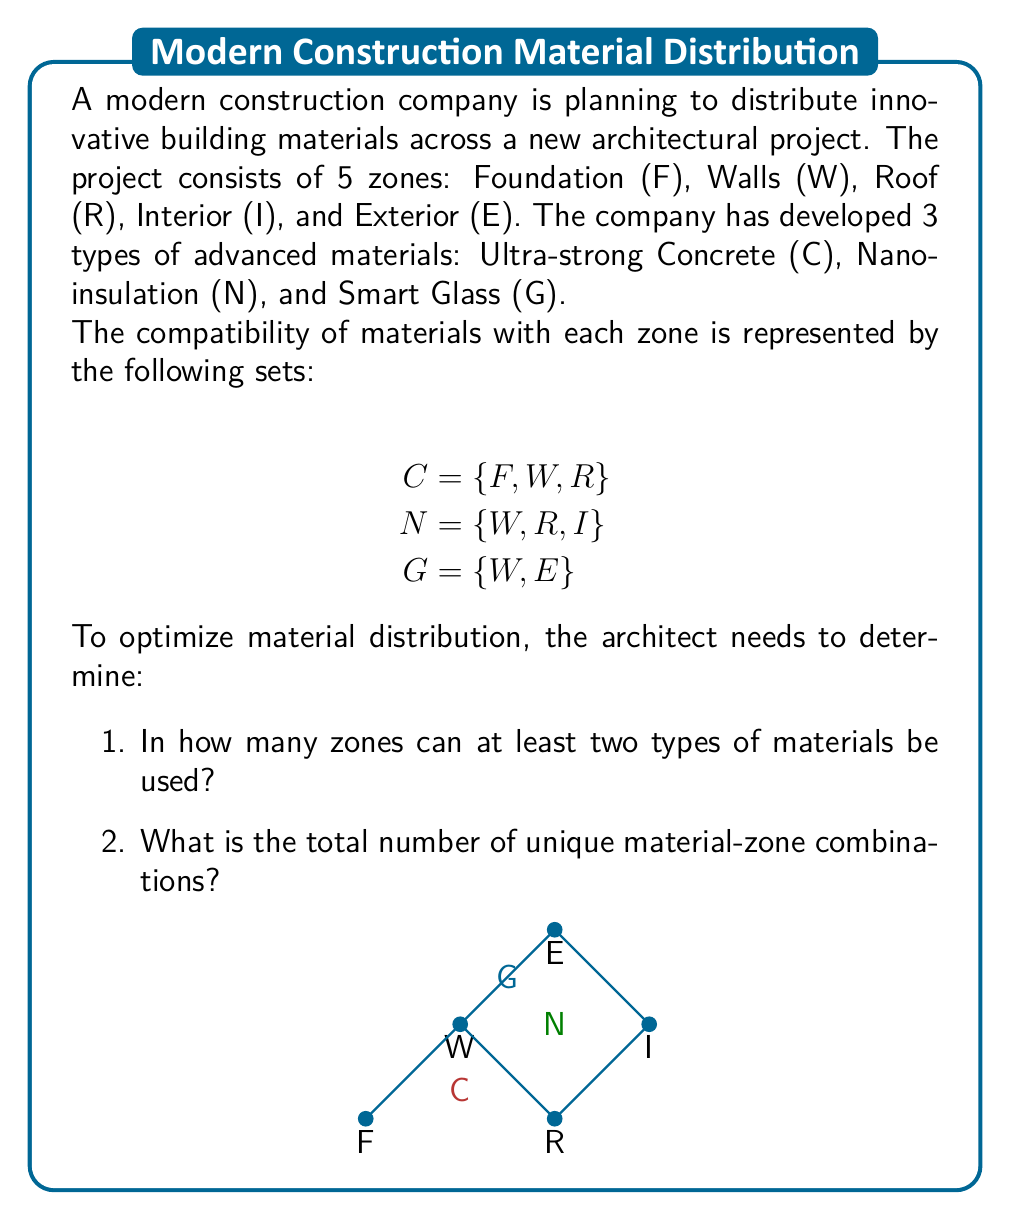Can you solve this math problem? Let's approach this problem step-by-step using set theory:

1. To find zones where at least two types of materials can be used:

   Let's create sets for each zone:
   $$\begin{align*}
   F &= \{C\} \\
   W &= \{C, N, G\} \\
   R &= \{C, N\} \\
   I &= \{N\} \\
   E &= \{G\}
   \end{align*}$$

   Zones with at least two materials: $W$ and $R$
   Count: 2 zones

2. To find the total number of unique material-zone combinations:

   We can use the sum of cardinalities of the material sets:
   $$|C| + |N| + |G| = 3 + 3 + 2 = 8$$

   However, this counts the overlapping zones multiple times. We need to subtract the overlaps:

   Overlaps:
   $$\begin{align*}
   |C \cap N| &= |\{W, R\}| = 2 \\
   |C \cap G| &= |\{W\}| = 1 \\
   |N \cap G| &= |\{W\}| = 1
   \end{align*}$$

   Using the Inclusion-Exclusion Principle:
   $$\text{Total} = |C \cup N \cup G|$$
   $$= |C| + |N| + |G| - |C \cap N| - |C \cap G| - |N \cap G| + |C \cap N \cap G|$$
   $$= 3 + 3 + 2 - 2 - 1 - 1 + |\{W\}|$$
   $$= 8 - 4 + 1 = 5$$

Therefore, there are 5 unique material-zone combinations.
Answer: 2 zones; 5 combinations 